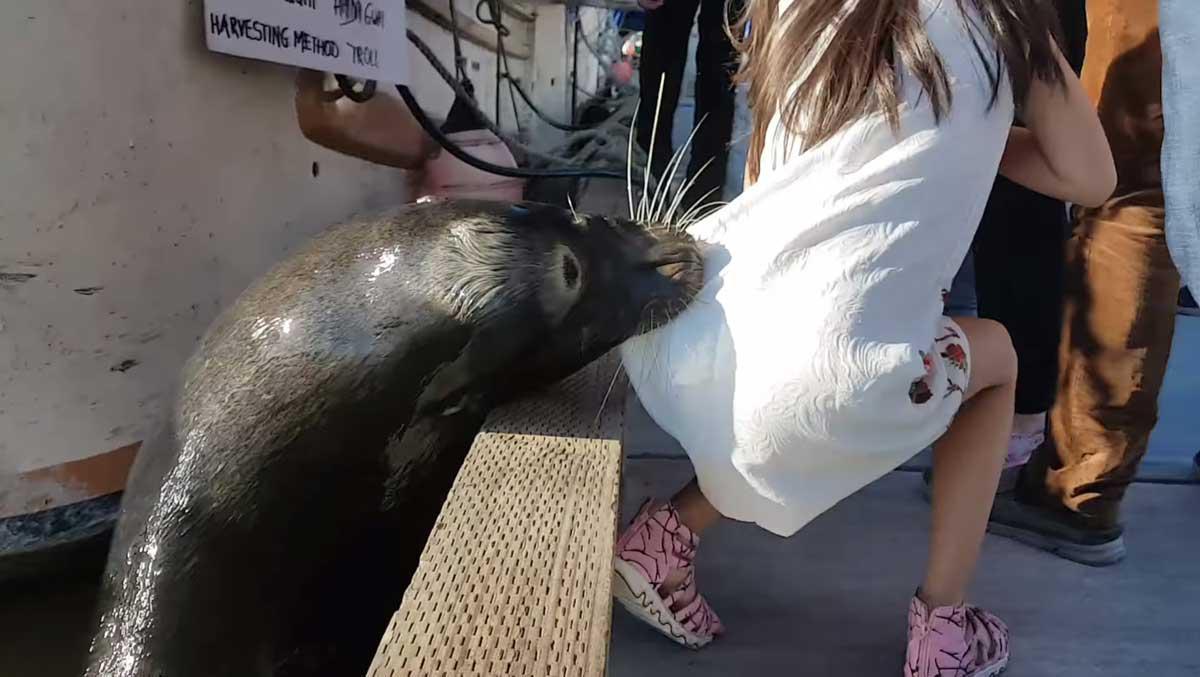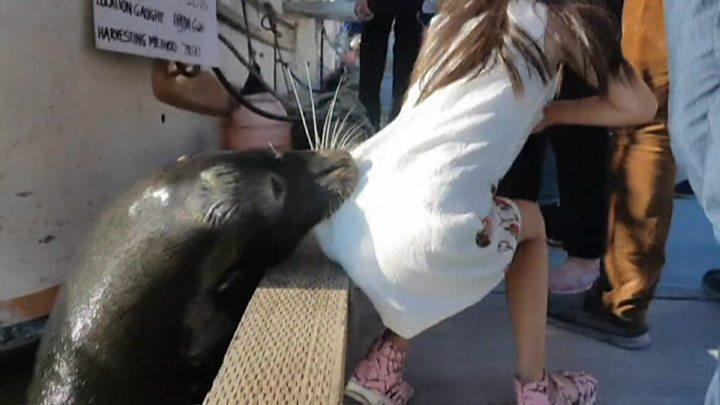The first image is the image on the left, the second image is the image on the right. Considering the images on both sides, is "In at least one of the images the girl's shoes are not visible." valid? Answer yes or no. No. 